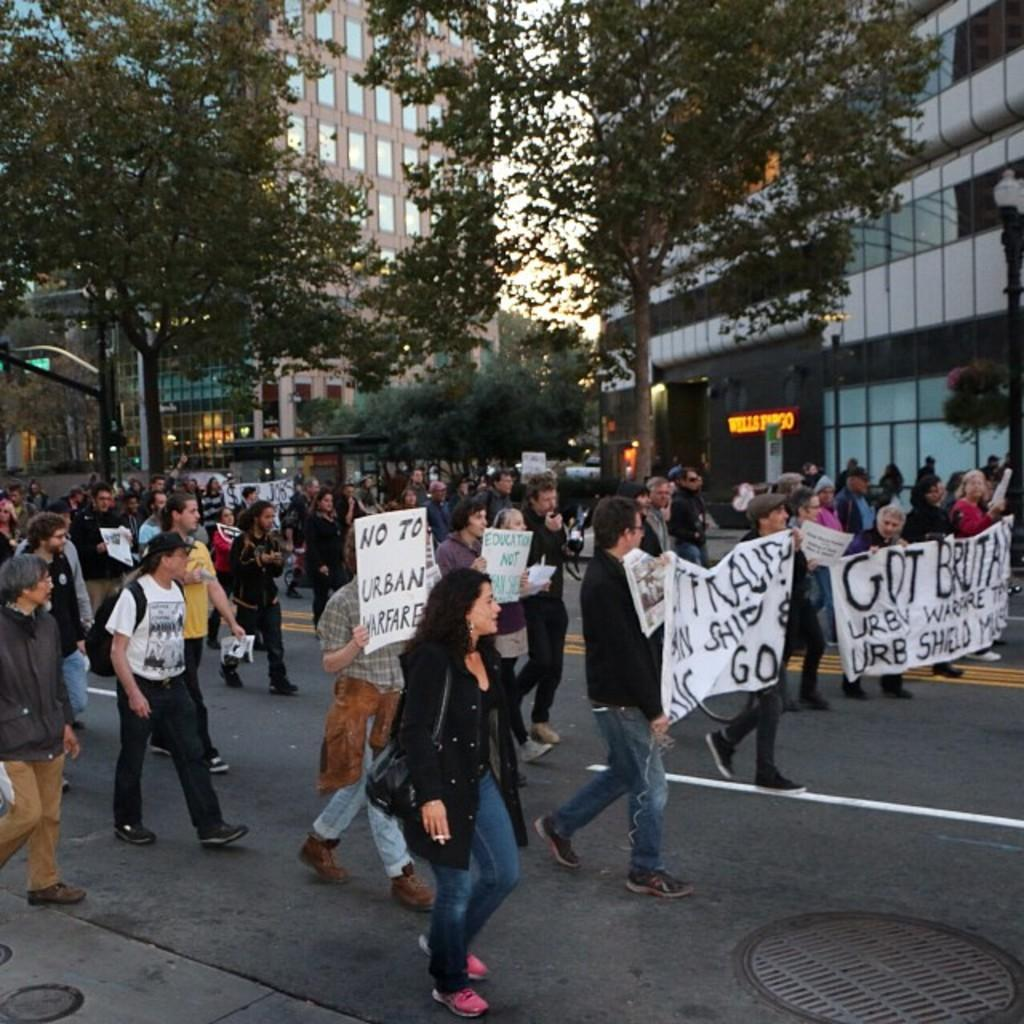What are the people in the image doing? The people in the image are holding banners. What is the location of the people in the image? The people are walking on a road. What can be seen in the background of the image? There are trees and buildings visible in the background of the image. What type of jail can be seen in the image? There is no jail present in the image. How many wings are visible on the people in the image? The people in the image do not have wings, as they are human beings. 